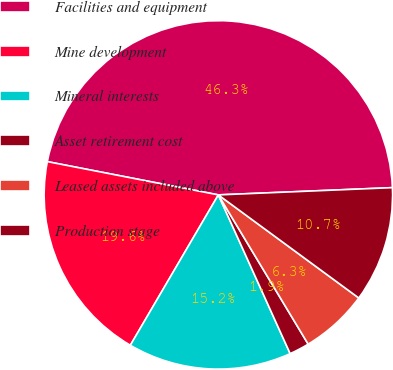Convert chart. <chart><loc_0><loc_0><loc_500><loc_500><pie_chart><fcel>Facilities and equipment<fcel>Mine development<fcel>Mineral interests<fcel>Asset retirement cost<fcel>Leased assets included above<fcel>Production stage<nl><fcel>46.28%<fcel>19.63%<fcel>15.19%<fcel>1.86%<fcel>6.3%<fcel>10.74%<nl></chart> 